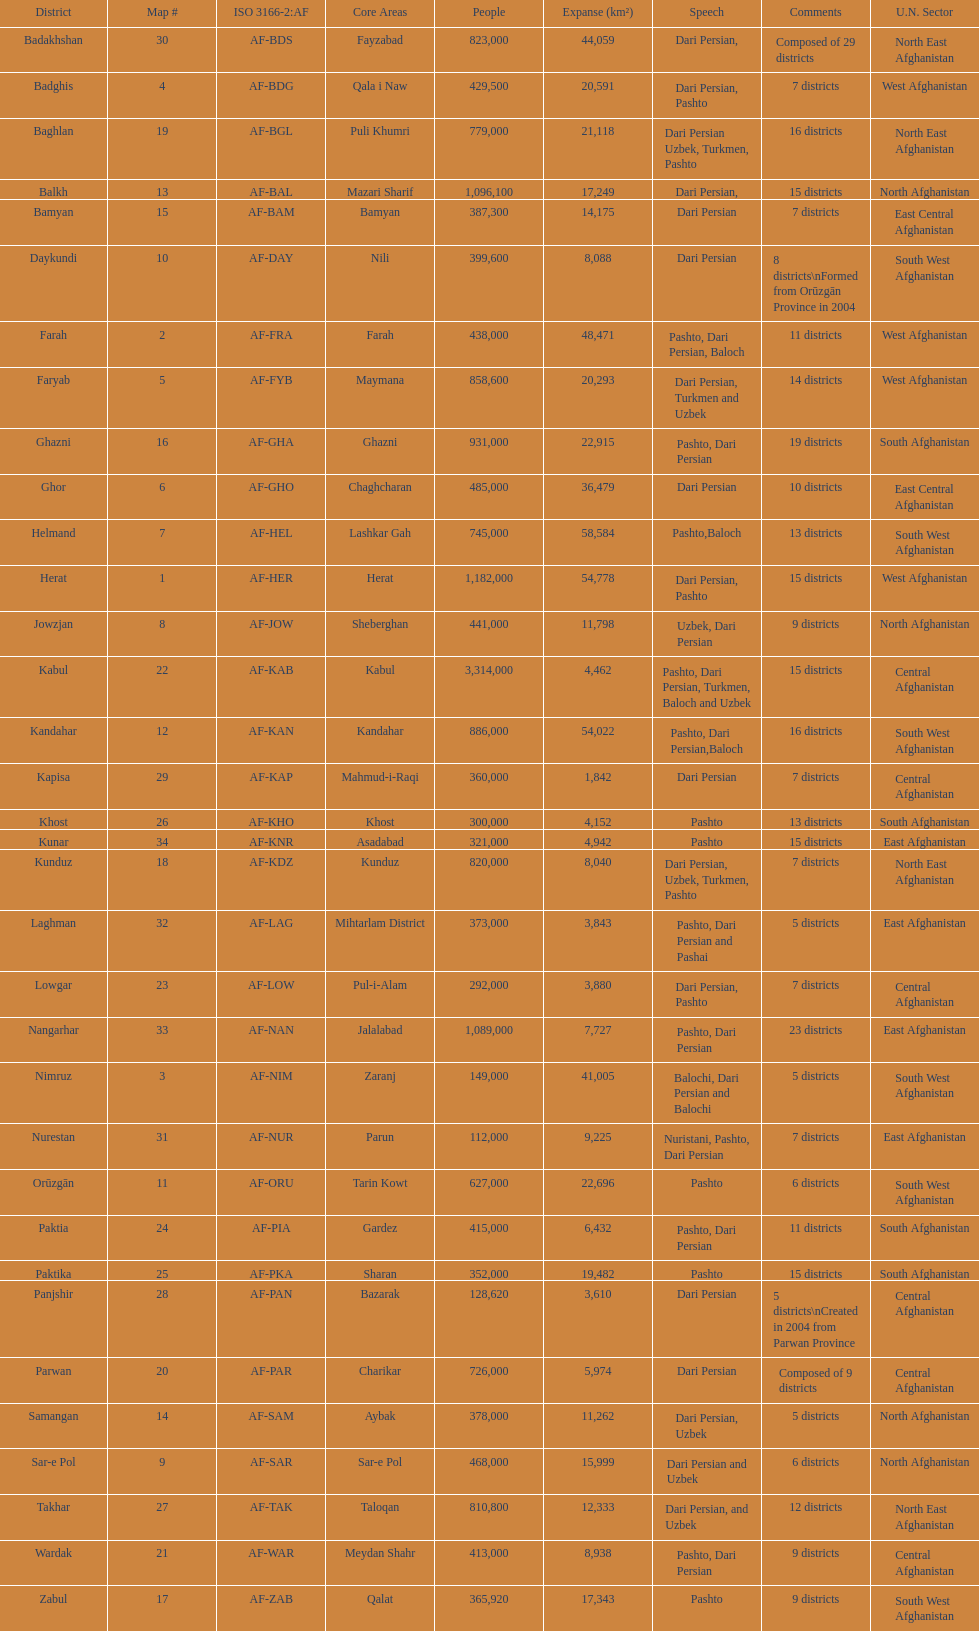Which province has the most districts? Badakhshan. 